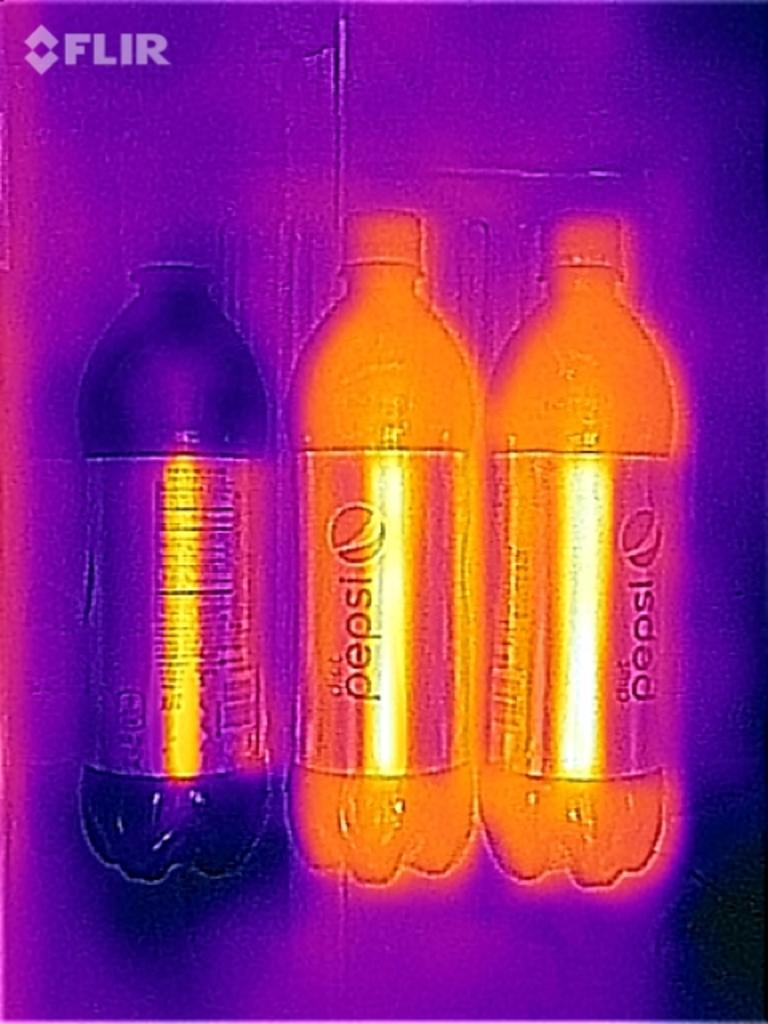What type of bottles are in the image? There are Pepsi bottles in the image. What color are the Pepsi bottles? The Pepsi bottles are in orange color. Can you describe the bottle on the left side of the image? There is a bottle in black color on the left side of the image. What type of art can be seen on the sofa in the image? There is no sofa or art present in the image; it only features Pepsi bottles and a black bottle. 